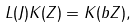<formula> <loc_0><loc_0><loc_500><loc_500>L ( J ) K ( Z ) = K ( b Z ) ,</formula> 